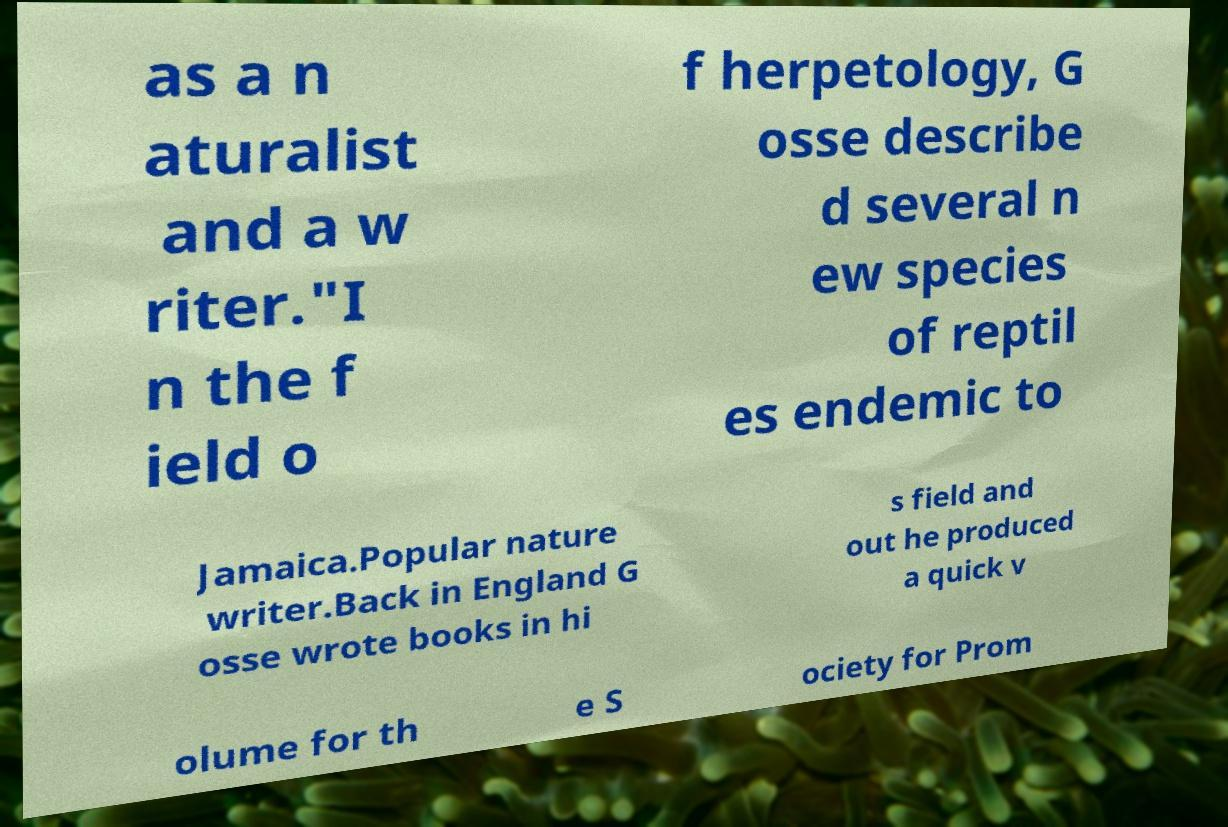There's text embedded in this image that I need extracted. Can you transcribe it verbatim? as a n aturalist and a w riter."I n the f ield o f herpetology, G osse describe d several n ew species of reptil es endemic to Jamaica.Popular nature writer.Back in England G osse wrote books in hi s field and out he produced a quick v olume for th e S ociety for Prom 